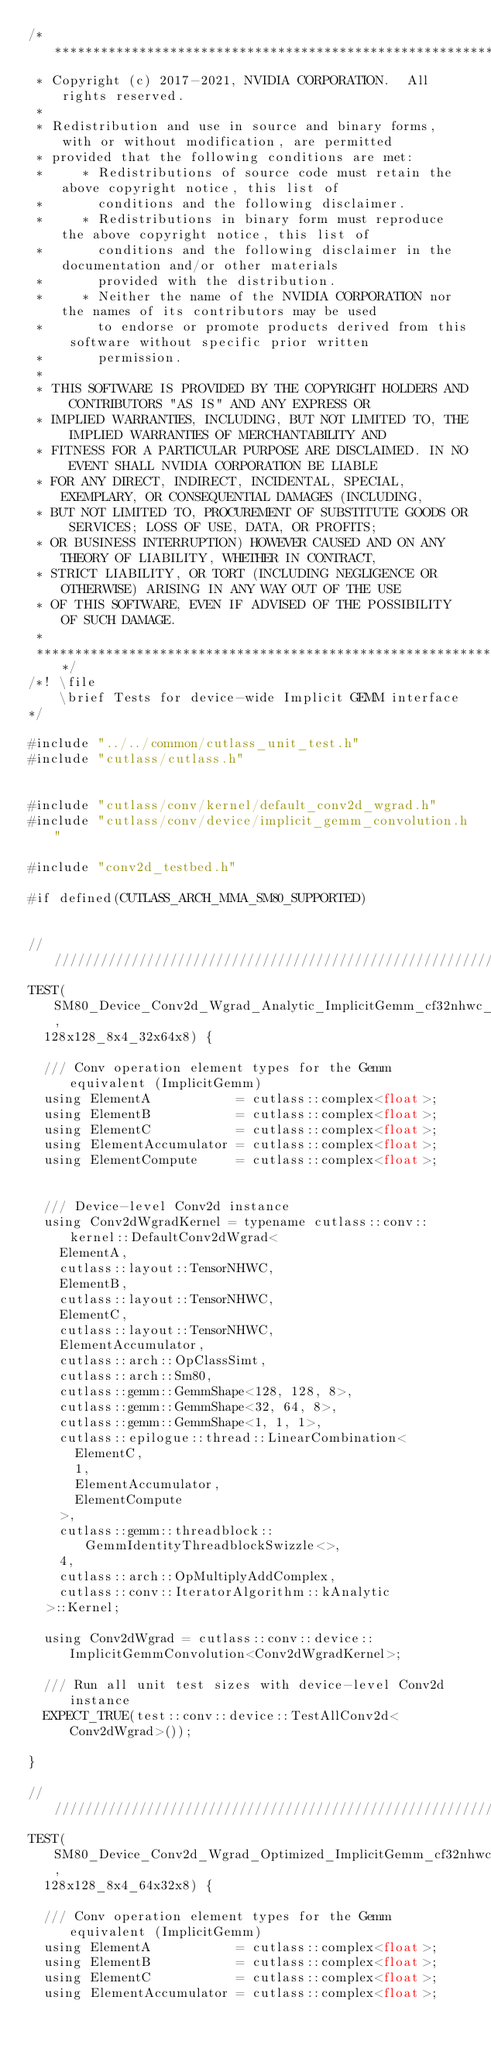<code> <loc_0><loc_0><loc_500><loc_500><_Cuda_>/***************************************************************************************************
 * Copyright (c) 2017-2021, NVIDIA CORPORATION.  All rights reserved.
 *
 * Redistribution and use in source and binary forms, with or without modification, are permitted
 * provided that the following conditions are met:
 *     * Redistributions of source code must retain the above copyright notice, this list of
 *       conditions and the following disclaimer.
 *     * Redistributions in binary form must reproduce the above copyright notice, this list of
 *       conditions and the following disclaimer in the documentation and/or other materials
 *       provided with the distribution.
 *     * Neither the name of the NVIDIA CORPORATION nor the names of its contributors may be used
 *       to endorse or promote products derived from this software without specific prior written
 *       permission.
 *
 * THIS SOFTWARE IS PROVIDED BY THE COPYRIGHT HOLDERS AND CONTRIBUTORS "AS IS" AND ANY EXPRESS OR
 * IMPLIED WARRANTIES, INCLUDING, BUT NOT LIMITED TO, THE IMPLIED WARRANTIES OF MERCHANTABILITY AND
 * FITNESS FOR A PARTICULAR PURPOSE ARE DISCLAIMED. IN NO EVENT SHALL NVIDIA CORPORATION BE LIABLE
 * FOR ANY DIRECT, INDIRECT, INCIDENTAL, SPECIAL, EXEMPLARY, OR CONSEQUENTIAL DAMAGES (INCLUDING,
 * BUT NOT LIMITED TO, PROCUREMENT OF SUBSTITUTE GOODS OR SERVICES; LOSS OF USE, DATA, OR PROFITS;
 * OR BUSINESS INTERRUPTION) HOWEVER CAUSED AND ON ANY THEORY OF LIABILITY, WHETHER IN CONTRACT,
 * STRICT LIABILITY, OR TORT (INCLUDING NEGLIGENCE OR OTHERWISE) ARISING IN ANY WAY OUT OF THE USE
 * OF THIS SOFTWARE, EVEN IF ADVISED OF THE POSSIBILITY OF SUCH DAMAGE.
 *
 **************************************************************************************************/
/*! \file
    \brief Tests for device-wide Implicit GEMM interface
*/

#include "../../common/cutlass_unit_test.h"
#include "cutlass/cutlass.h"


#include "cutlass/conv/kernel/default_conv2d_wgrad.h"
#include "cutlass/conv/device/implicit_gemm_convolution.h"

#include "conv2d_testbed.h"

#if defined(CUTLASS_ARCH_MMA_SM80_SUPPORTED)


////////////////////////////////////////////////////////////////////////////////
TEST(SM80_Device_Conv2d_Wgrad_Analytic_ImplicitGemm_cf32nhwc_cf32nhwc_cf32nhwc_simt_f32,
  128x128_8x4_32x64x8) {

  /// Conv operation element types for the Gemm equivalent (ImplicitGemm)
  using ElementA           = cutlass::complex<float>;
  using ElementB           = cutlass::complex<float>;
  using ElementC           = cutlass::complex<float>;
  using ElementAccumulator = cutlass::complex<float>;
  using ElementCompute     = cutlass::complex<float>;


  /// Device-level Conv2d instance
  using Conv2dWgradKernel = typename cutlass::conv::kernel::DefaultConv2dWgrad<
    ElementA, 
    cutlass::layout::TensorNHWC,
    ElementB, 
    cutlass::layout::TensorNHWC,
    ElementC, 
    cutlass::layout::TensorNHWC,
    ElementAccumulator,
    cutlass::arch::OpClassSimt,
    cutlass::arch::Sm80,
    cutlass::gemm::GemmShape<128, 128, 8>,
    cutlass::gemm::GemmShape<32, 64, 8>, 
    cutlass::gemm::GemmShape<1, 1, 1>,
    cutlass::epilogue::thread::LinearCombination<
      ElementC,
      1,
      ElementAccumulator,
      ElementCompute
    >,
    cutlass::gemm::threadblock::GemmIdentityThreadblockSwizzle<>,
    4,
    cutlass::arch::OpMultiplyAddComplex,
    cutlass::conv::IteratorAlgorithm::kAnalytic
  >::Kernel;

  using Conv2dWgrad = cutlass::conv::device::ImplicitGemmConvolution<Conv2dWgradKernel>;

  /// Run all unit test sizes with device-level Conv2d instance
  EXPECT_TRUE(test::conv::device::TestAllConv2d<Conv2dWgrad>());

}

////////////////////////////////////////////////////////////////////////////////
TEST(SM80_Device_Conv2d_Wgrad_Optimized_ImplicitGemm_cf32nhwc_cf32nhwc_cf32nhwc_simt_f32,
  128x128_8x4_64x32x8) {

  /// Conv operation element types for the Gemm equivalent (ImplicitGemm)
  using ElementA           = cutlass::complex<float>;
  using ElementB           = cutlass::complex<float>;
  using ElementC           = cutlass::complex<float>;
  using ElementAccumulator = cutlass::complex<float>;</code> 